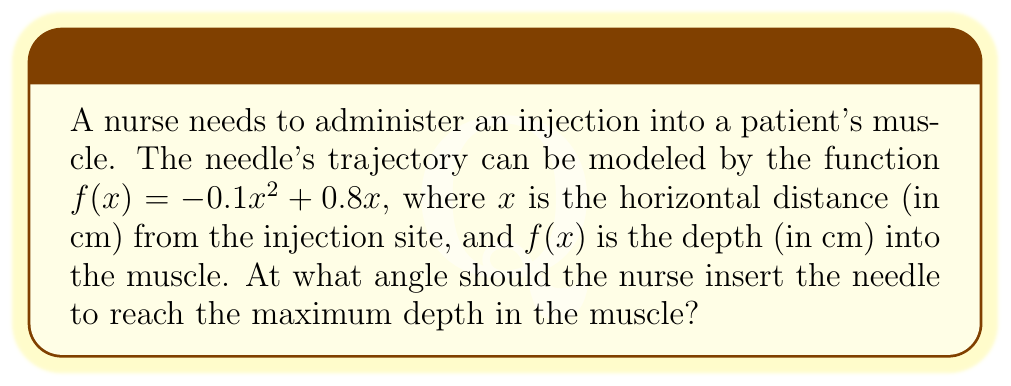Can you answer this question? To find the optimal angle for the injection, we need to follow these steps:

1) First, we need to find the maximum point of the function $f(x) = -0.1x^2 + 0.8x$. This occurs where the derivative $f'(x) = 0$.

2) The derivative of $f(x)$ is:
   $f'(x) = -0.2x + 0.8$

3) Set $f'(x) = 0$ and solve for $x$:
   $-0.2x + 0.8 = 0$
   $-0.2x = -0.8$
   $x = 4$

4) The maximum depth occurs at $x = 4$ cm. To find the depth, substitute this back into the original function:
   $f(4) = -0.1(4)^2 + 0.8(4) = -1.6 + 3.2 = 1.6$ cm

5) Now we have a right triangle with base 4 cm and height 1.6 cm. We can find the angle using the arctangent function:
   $\theta = \arctan(\frac{1.6}{4}) = \arctan(0.4)$

6) Converting to degrees:
   $\theta \approx 21.8°$

Therefore, the optimal angle for the injection is approximately 21.8° from the horizontal.
Answer: $21.8°$ 